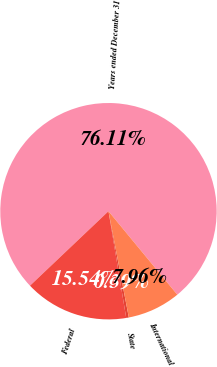Convert chart. <chart><loc_0><loc_0><loc_500><loc_500><pie_chart><fcel>Years ended December 31<fcel>Federal<fcel>State<fcel>International<nl><fcel>76.11%<fcel>15.54%<fcel>0.39%<fcel>7.96%<nl></chart> 